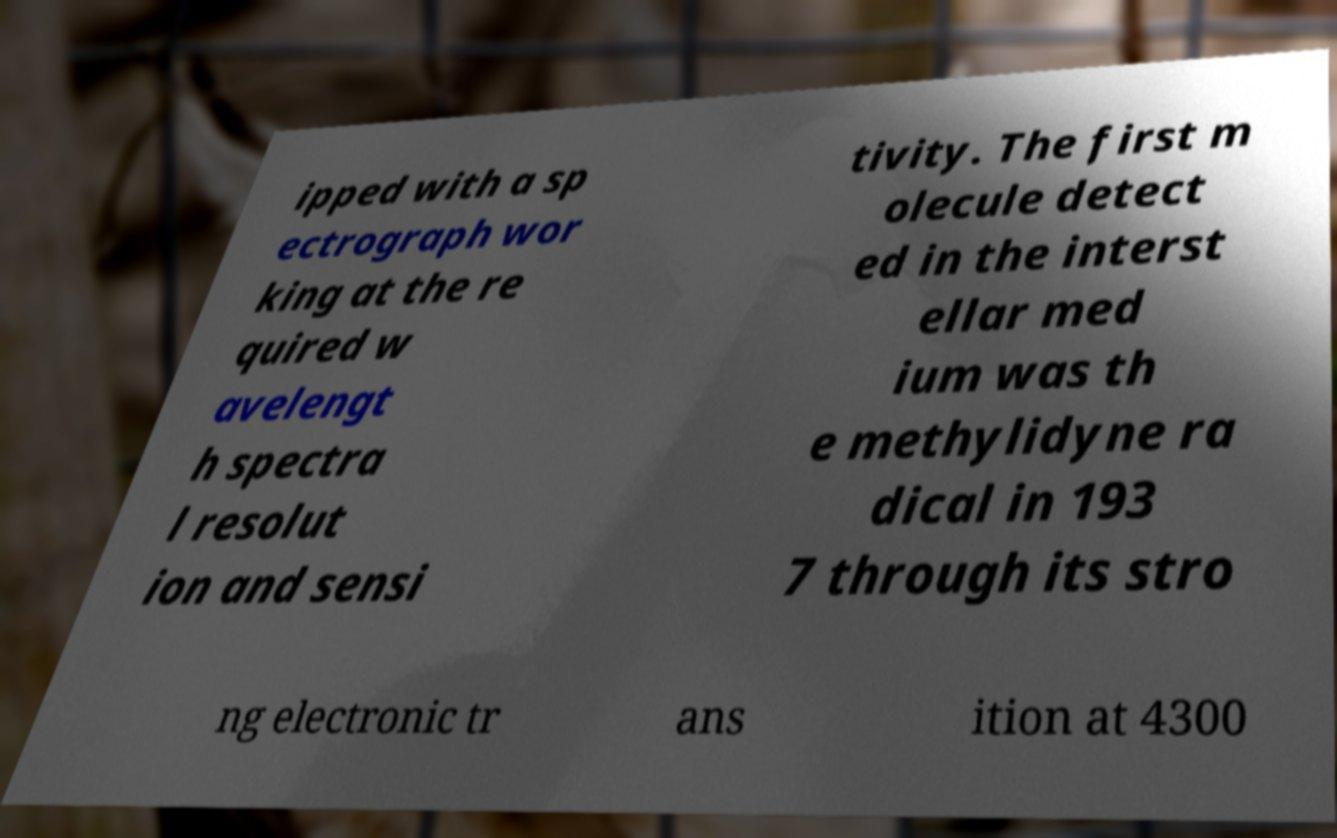For documentation purposes, I need the text within this image transcribed. Could you provide that? ipped with a sp ectrograph wor king at the re quired w avelengt h spectra l resolut ion and sensi tivity. The first m olecule detect ed in the interst ellar med ium was th e methylidyne ra dical in 193 7 through its stro ng electronic tr ans ition at 4300 